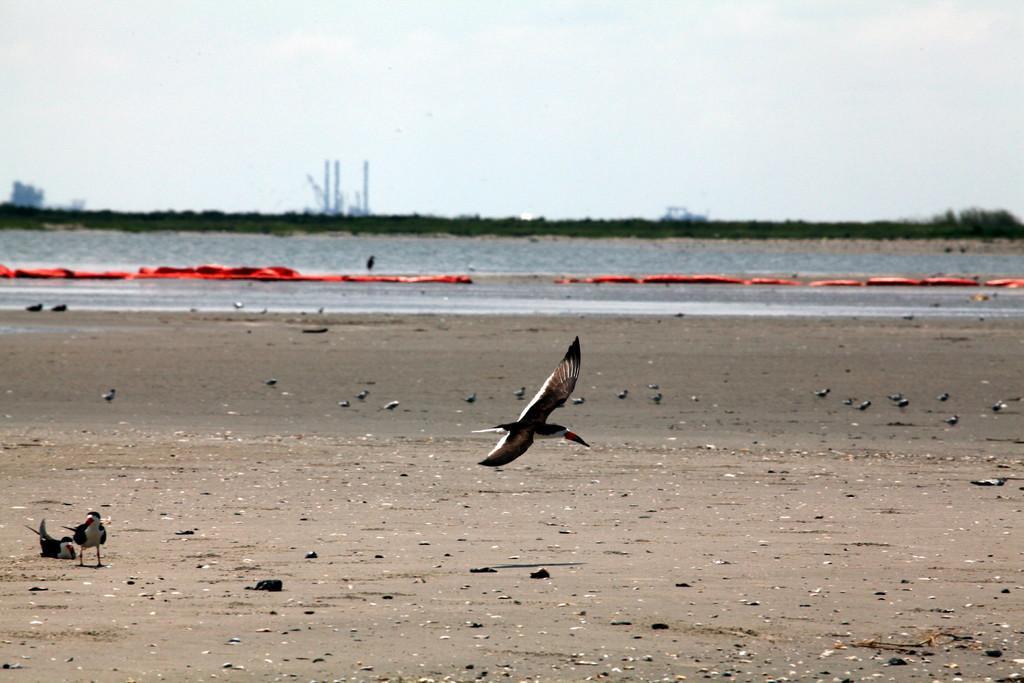Can you describe this image briefly? In this picture there is a flying bird in the center of the image and there are birds in the center of the image, on a muddy area and there are trees, poles, and water in the background area of the image. 